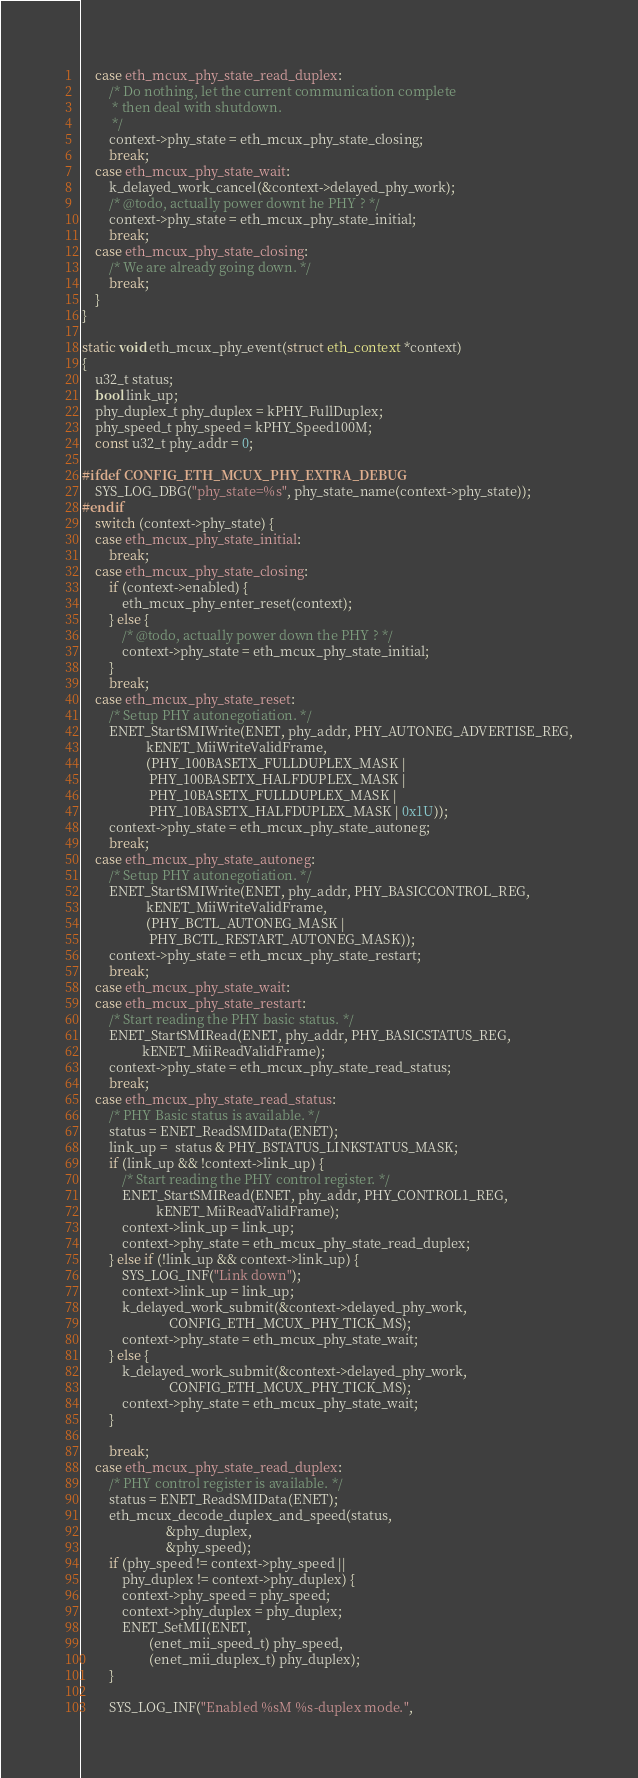Convert code to text. <code><loc_0><loc_0><loc_500><loc_500><_C_>	case eth_mcux_phy_state_read_duplex:
		/* Do nothing, let the current communication complete
		 * then deal with shutdown.
		 */
		context->phy_state = eth_mcux_phy_state_closing;
		break;
	case eth_mcux_phy_state_wait:
		k_delayed_work_cancel(&context->delayed_phy_work);
		/* @todo, actually power downt he PHY ? */
		context->phy_state = eth_mcux_phy_state_initial;
		break;
	case eth_mcux_phy_state_closing:
		/* We are already going down. */
		break;
	}
}

static void eth_mcux_phy_event(struct eth_context *context)
{
	u32_t status;
	bool link_up;
	phy_duplex_t phy_duplex = kPHY_FullDuplex;
	phy_speed_t phy_speed = kPHY_Speed100M;
	const u32_t phy_addr = 0;

#ifdef CONFIG_ETH_MCUX_PHY_EXTRA_DEBUG
	SYS_LOG_DBG("phy_state=%s", phy_state_name(context->phy_state));
#endif
	switch (context->phy_state) {
	case eth_mcux_phy_state_initial:
		break;
	case eth_mcux_phy_state_closing:
		if (context->enabled) {
			eth_mcux_phy_enter_reset(context);
		} else {
			/* @todo, actually power down the PHY ? */
			context->phy_state = eth_mcux_phy_state_initial;
		}
		break;
	case eth_mcux_phy_state_reset:
		/* Setup PHY autonegotiation. */
		ENET_StartSMIWrite(ENET, phy_addr, PHY_AUTONEG_ADVERTISE_REG,
				   kENET_MiiWriteValidFrame,
				   (PHY_100BASETX_FULLDUPLEX_MASK |
				    PHY_100BASETX_HALFDUPLEX_MASK |
				    PHY_10BASETX_FULLDUPLEX_MASK |
				    PHY_10BASETX_HALFDUPLEX_MASK | 0x1U));
		context->phy_state = eth_mcux_phy_state_autoneg;
		break;
	case eth_mcux_phy_state_autoneg:
		/* Setup PHY autonegotiation. */
		ENET_StartSMIWrite(ENET, phy_addr, PHY_BASICCONTROL_REG,
				   kENET_MiiWriteValidFrame,
				   (PHY_BCTL_AUTONEG_MASK |
				    PHY_BCTL_RESTART_AUTONEG_MASK));
		context->phy_state = eth_mcux_phy_state_restart;
		break;
	case eth_mcux_phy_state_wait:
	case eth_mcux_phy_state_restart:
		/* Start reading the PHY basic status. */
		ENET_StartSMIRead(ENET, phy_addr, PHY_BASICSTATUS_REG,
				  kENET_MiiReadValidFrame);
		context->phy_state = eth_mcux_phy_state_read_status;
		break;
	case eth_mcux_phy_state_read_status:
		/* PHY Basic status is available. */
		status = ENET_ReadSMIData(ENET);
		link_up =  status & PHY_BSTATUS_LINKSTATUS_MASK;
		if (link_up && !context->link_up) {
			/* Start reading the PHY control register. */
			ENET_StartSMIRead(ENET, phy_addr, PHY_CONTROL1_REG,
					  kENET_MiiReadValidFrame);
			context->link_up = link_up;
			context->phy_state = eth_mcux_phy_state_read_duplex;
		} else if (!link_up && context->link_up) {
			SYS_LOG_INF("Link down");
			context->link_up = link_up;
			k_delayed_work_submit(&context->delayed_phy_work,
					      CONFIG_ETH_MCUX_PHY_TICK_MS);
			context->phy_state = eth_mcux_phy_state_wait;
		} else {
			k_delayed_work_submit(&context->delayed_phy_work,
					      CONFIG_ETH_MCUX_PHY_TICK_MS);
			context->phy_state = eth_mcux_phy_state_wait;
		}

		break;
	case eth_mcux_phy_state_read_duplex:
		/* PHY control register is available. */
		status = ENET_ReadSMIData(ENET);
		eth_mcux_decode_duplex_and_speed(status,
						 &phy_duplex,
						 &phy_speed);
		if (phy_speed != context->phy_speed ||
		    phy_duplex != context->phy_duplex) {
			context->phy_speed = phy_speed;
			context->phy_duplex = phy_duplex;
			ENET_SetMII(ENET,
				    (enet_mii_speed_t) phy_speed,
				    (enet_mii_duplex_t) phy_duplex);
		}

		SYS_LOG_INF("Enabled %sM %s-duplex mode.",</code> 